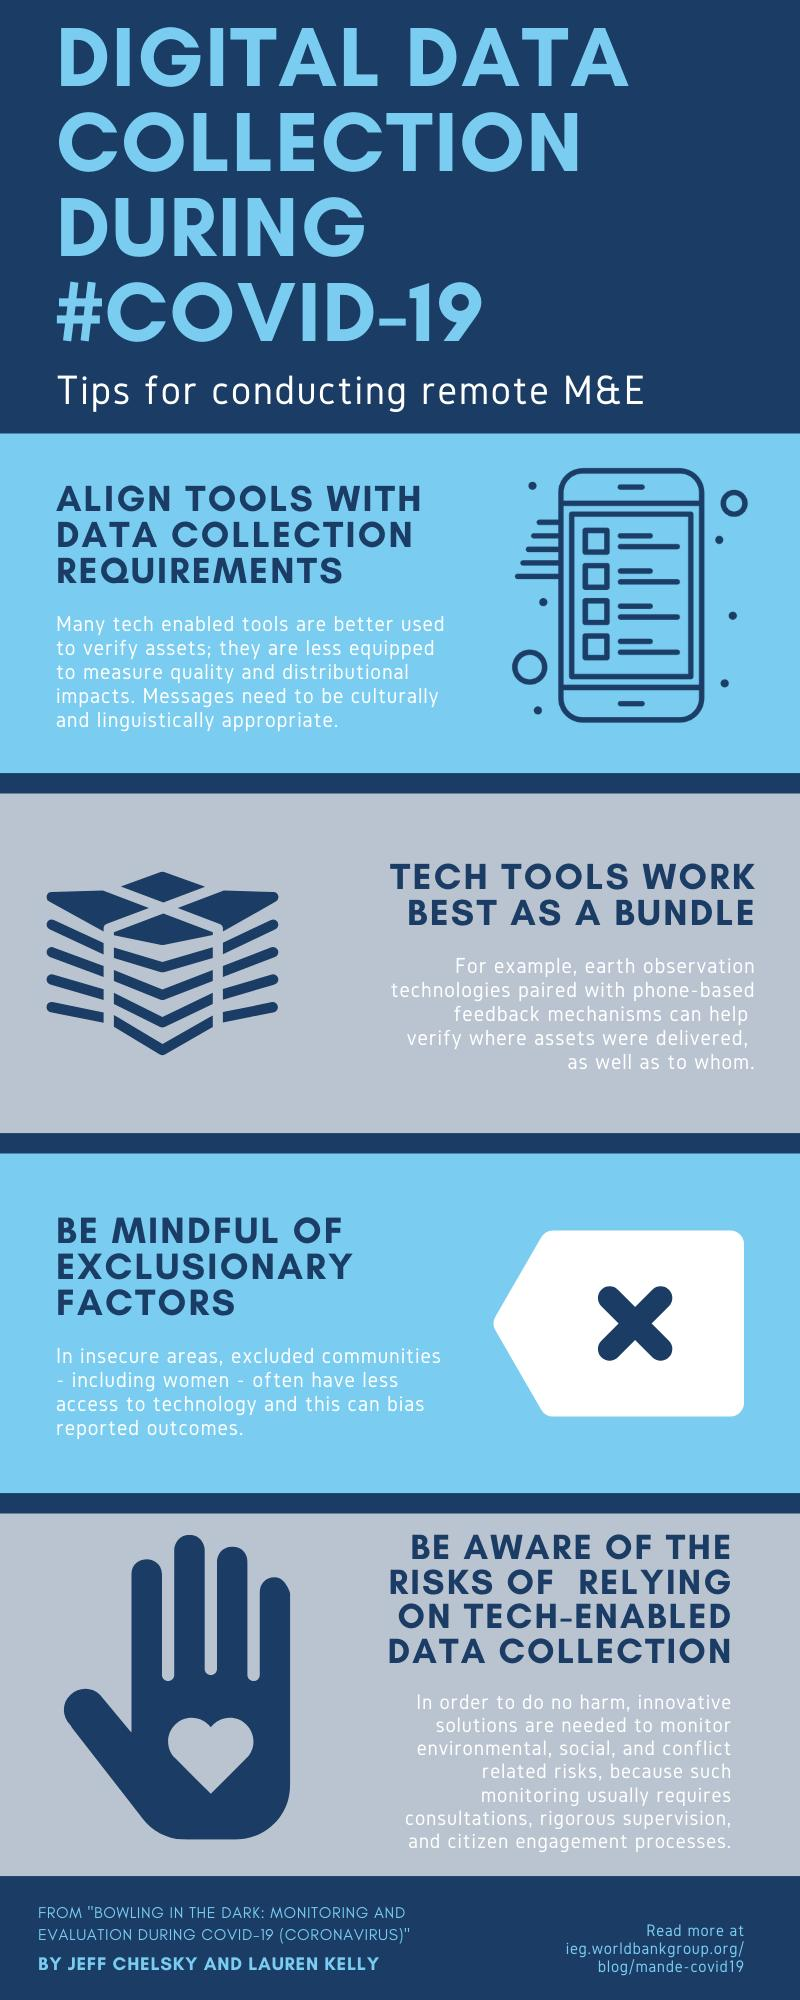Specify some key components in this picture. The symbol used to represent the first tip-mobile or TV is mobile. There are four tips for conducting effective monitoring and evaluation of remote projects. 